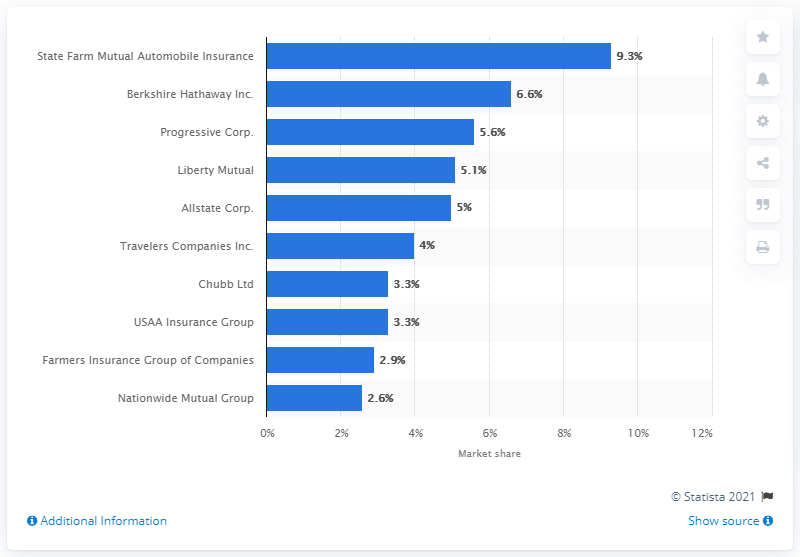Give some essential details in this illustration. According to data from 2019, Liberty Mutual was ranked fourth in terms of market share with a 5.1 percent market share. 